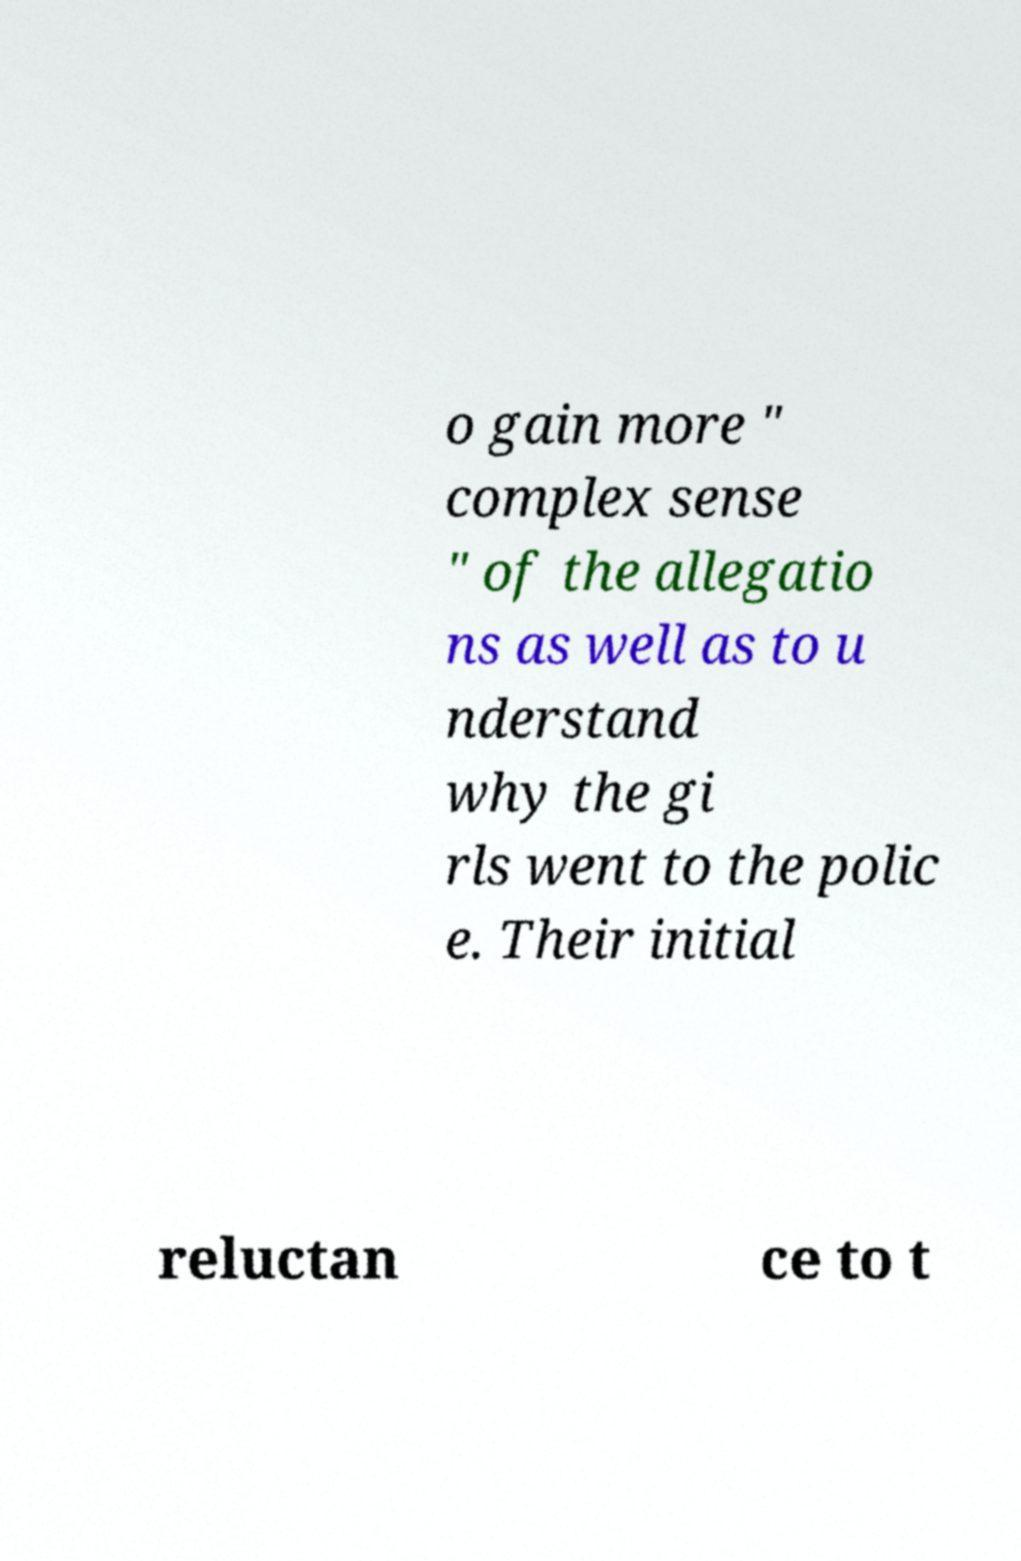Can you read and provide the text displayed in the image?This photo seems to have some interesting text. Can you extract and type it out for me? o gain more " complex sense " of the allegatio ns as well as to u nderstand why the gi rls went to the polic e. Their initial reluctan ce to t 